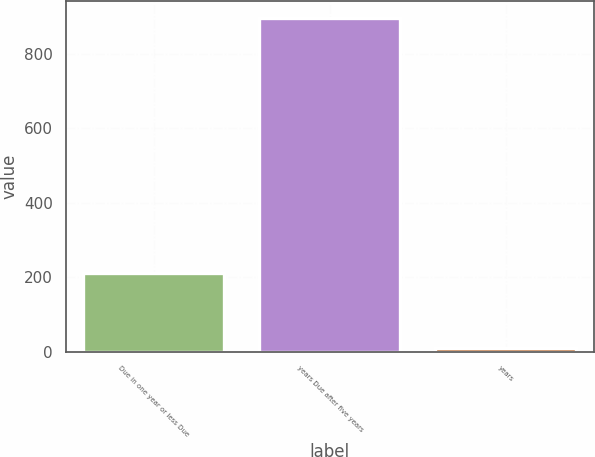Convert chart. <chart><loc_0><loc_0><loc_500><loc_500><bar_chart><fcel>Due in one year or less Due<fcel>years Due after five years<fcel>years<nl><fcel>211<fcel>898<fcel>10<nl></chart> 